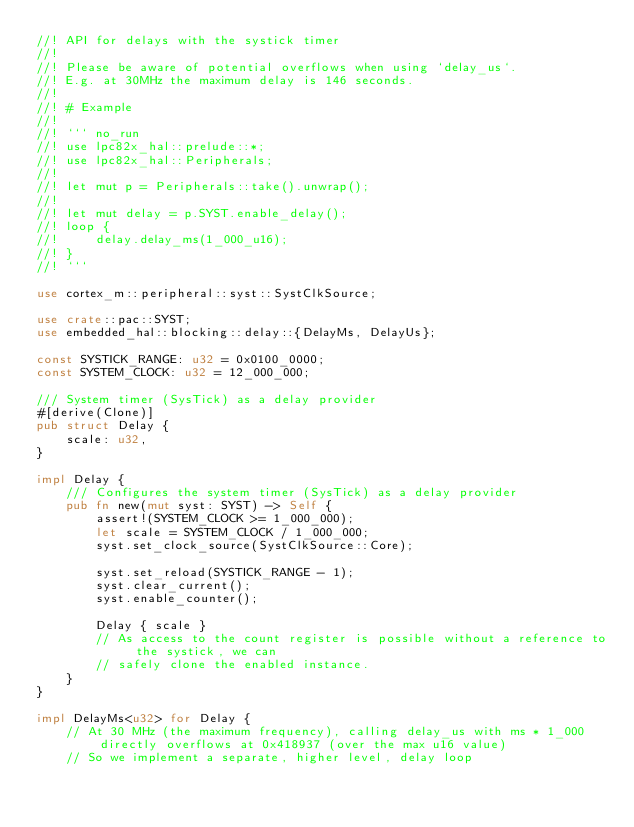<code> <loc_0><loc_0><loc_500><loc_500><_Rust_>//! API for delays with the systick timer
//!
//! Please be aware of potential overflows when using `delay_us`.
//! E.g. at 30MHz the maximum delay is 146 seconds.
//!
//! # Example
//!
//! ``` no_run
//! use lpc82x_hal::prelude::*;
//! use lpc82x_hal::Peripherals;
//!
//! let mut p = Peripherals::take().unwrap();
//!
//! let mut delay = p.SYST.enable_delay();
//! loop {
//!     delay.delay_ms(1_000_u16);
//! }
//! ```

use cortex_m::peripheral::syst::SystClkSource;

use crate::pac::SYST;
use embedded_hal::blocking::delay::{DelayMs, DelayUs};

const SYSTICK_RANGE: u32 = 0x0100_0000;
const SYSTEM_CLOCK: u32 = 12_000_000;

/// System timer (SysTick) as a delay provider
#[derive(Clone)]
pub struct Delay {
    scale: u32,
}

impl Delay {
    /// Configures the system timer (SysTick) as a delay provider
    pub fn new(mut syst: SYST) -> Self {
        assert!(SYSTEM_CLOCK >= 1_000_000);
        let scale = SYSTEM_CLOCK / 1_000_000;
        syst.set_clock_source(SystClkSource::Core);

        syst.set_reload(SYSTICK_RANGE - 1);
        syst.clear_current();
        syst.enable_counter();

        Delay { scale }
        // As access to the count register is possible without a reference to the systick, we can
        // safely clone the enabled instance.
    }
}

impl DelayMs<u32> for Delay {
    // At 30 MHz (the maximum frequency), calling delay_us with ms * 1_000 directly overflows at 0x418937 (over the max u16 value)
    // So we implement a separate, higher level, delay loop</code> 